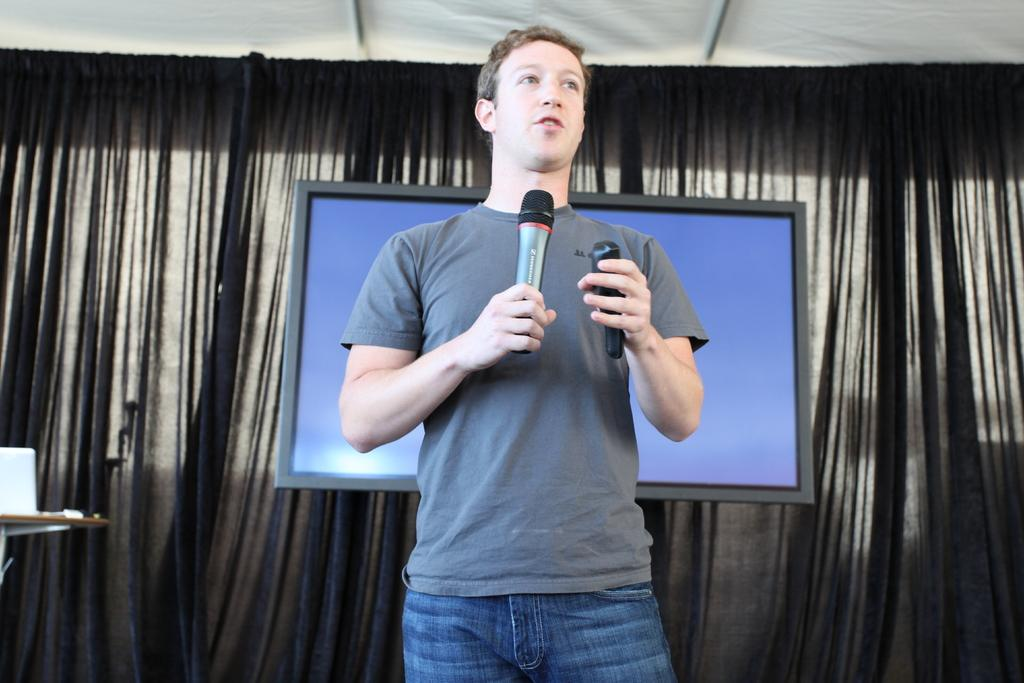Who is the main subject in the image? There is a man in the center of the image. What is the man doing in the image? The man is standing and appears to be talking. What is the man holding in the image? The man is holding a microphone. What can be seen in the background of the image? There is a curtain and a television in the background of the image. What type of fireman is the man in the image? The man in the image is not a fireman; he is holding a microphone and appears to be talking. What achievements has the man in the image accomplished? The image does not provide any information about the man's achievements or accomplishments. 